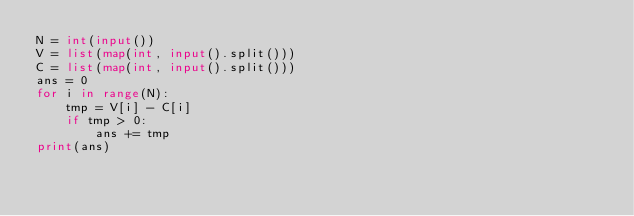<code> <loc_0><loc_0><loc_500><loc_500><_Python_>N = int(input())
V = list(map(int, input().split()))
C = list(map(int, input().split()))
ans = 0
for i in range(N):
    tmp = V[i] - C[i]
    if tmp > 0:
        ans += tmp
print(ans)</code> 